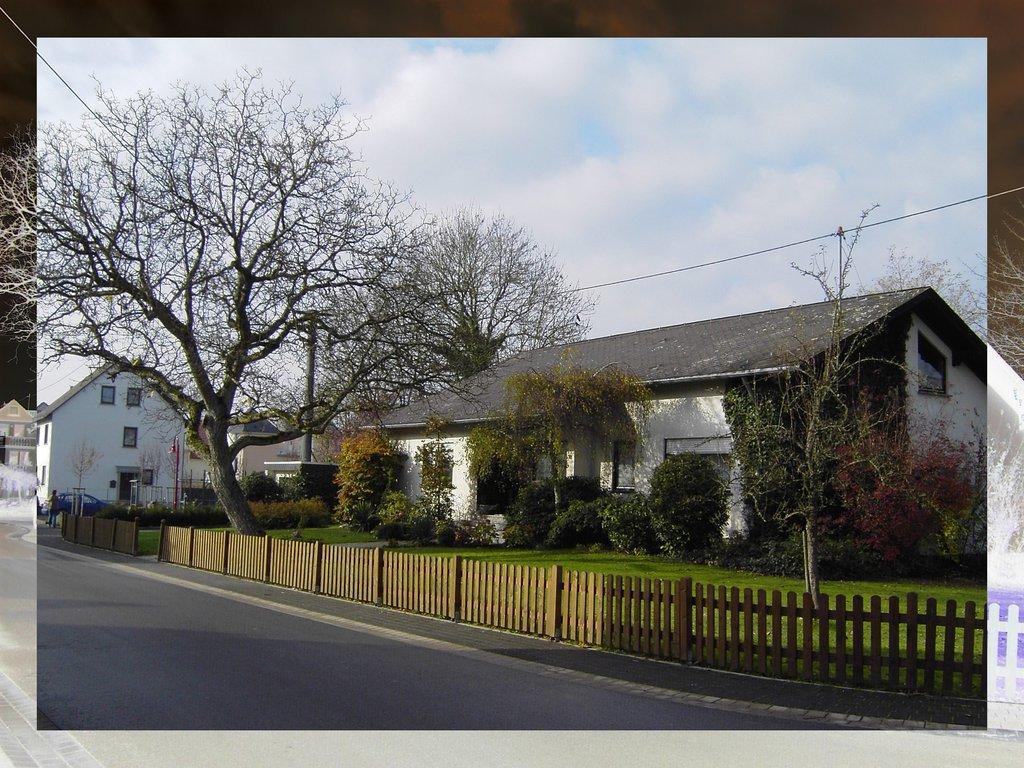Can you describe this image briefly? In the foreground of this edited image, on the bottom, there is a road and the railing. In the background, there are plants, trees, houses, a pole, cable, sky and the cloud. 